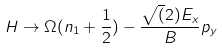Convert formula to latex. <formula><loc_0><loc_0><loc_500><loc_500>H \rightarrow \Omega ( n _ { 1 } + \frac { 1 } { 2 } ) - \frac { \sqrt { ( } 2 ) E _ { x } } { B } p _ { y }</formula> 